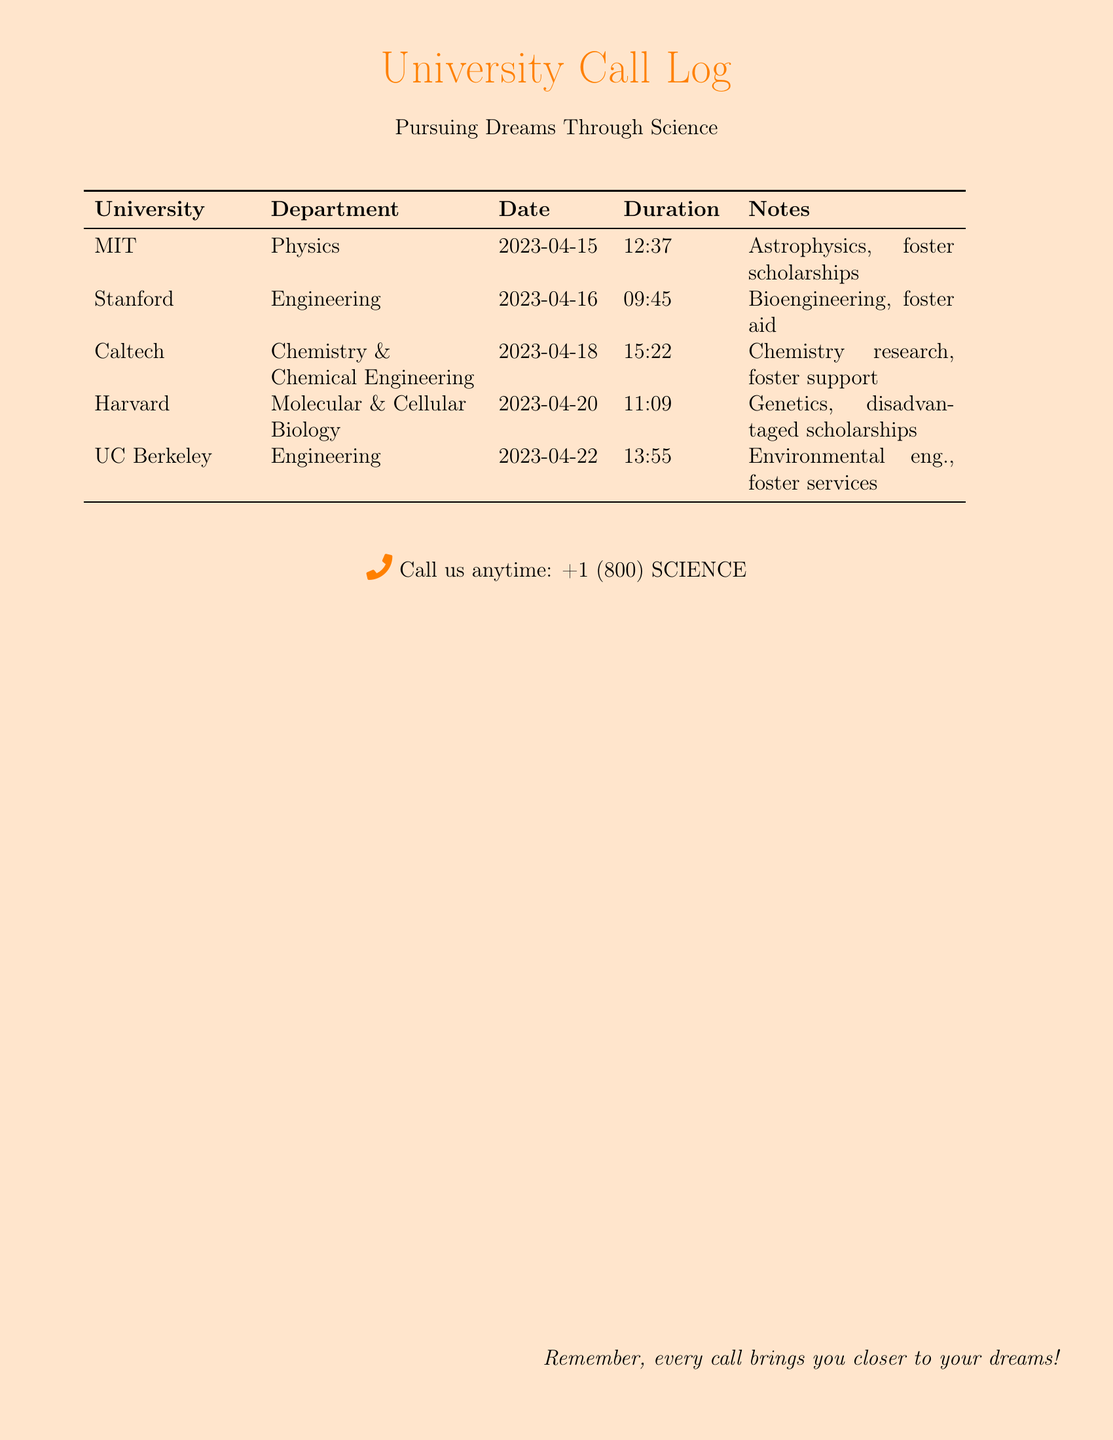What is the date of the call to MIT? The date of the call to MIT is listed in the document under the date column for MIT, which is 2023-04-15.
Answer: 2023-04-15 How long was the call to Stanford? The duration of the call to Stanford is provided in the duration column for Stanford, which is 09:45.
Answer: 09:45 What university is associated with chemistry research? The university associated with chemistry research is listed in the notes for Caltech, which mentions chemistry research specifically.
Answer: Caltech Which university offers foster scholarships? Foster scholarships are mentioned under MIT's notes, indicating that MIT offers such scholarships.
Answer: MIT How many universities are listed in the call log? The total number of universities can be found by counting each entry in the university column, which includes five entries.
Answer: 5 What is the main focus of the call made to UC Berkeley? The main focus for the call made to UC Berkeley is described in the notes section, which mentions environmental engineering.
Answer: Environmental eng Which department was contacted at Harvard? The department contacted at Harvard is specified in the department column as Molecular & Cellular Biology.
Answer: Molecular & Cellular Biology What type of educational support is mentioned for Harvard? The type of educational support mentioned for Harvard in the notes is disadvantaged scholarships.
Answer: Disadvantaged scholarships Which university was called on April 22, 2023? The university that was called on April 22, 2023, is provided in the date column for that specific call, which lists UC Berkeley.
Answer: UC Berkeley 